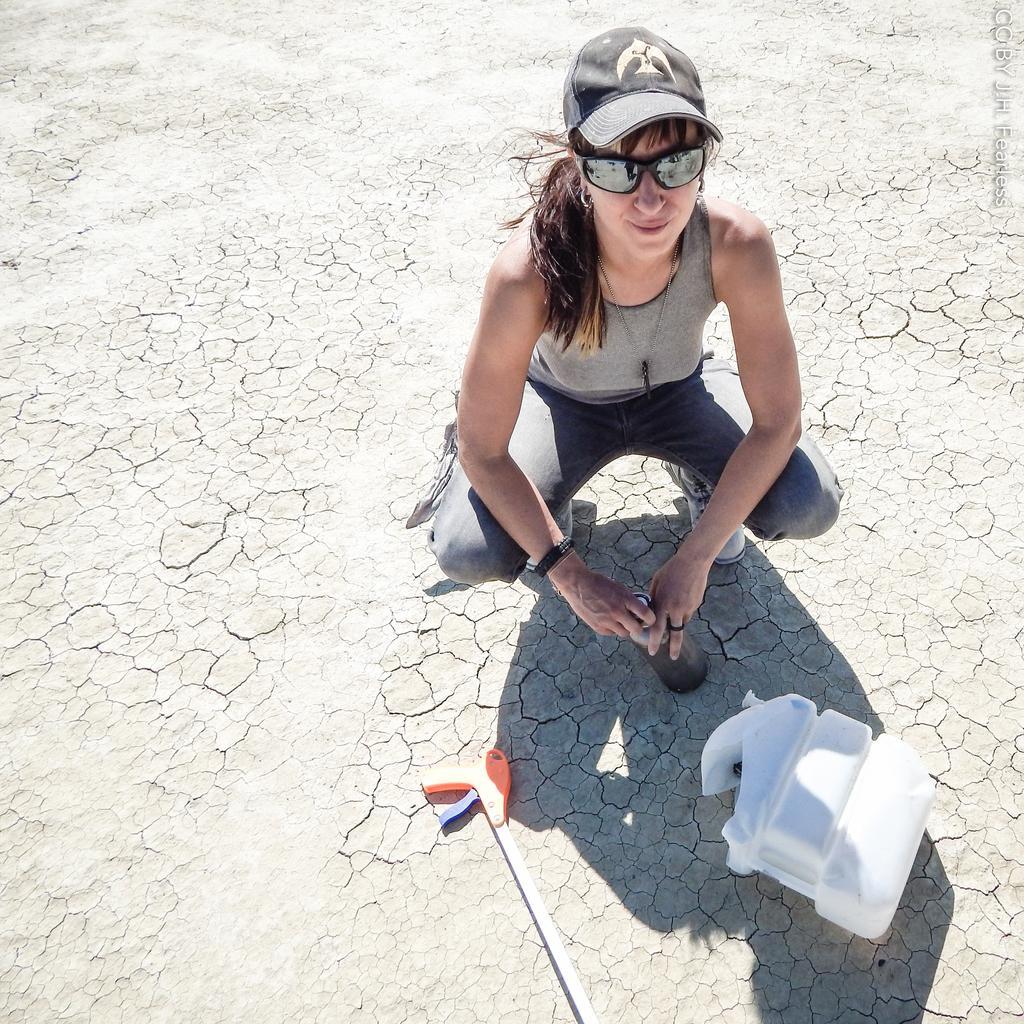Describe this image in one or two sentences. In this picture I can see a person wearing the cap and holding the bottle. I can see a few objects on the surface in the foreground. 